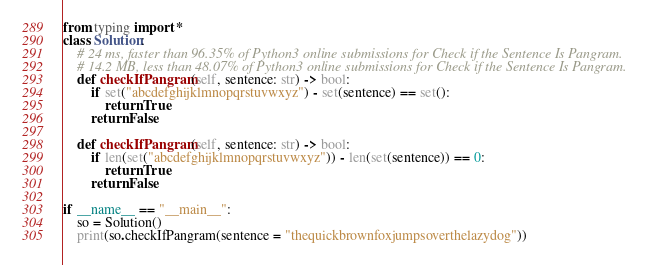Convert code to text. <code><loc_0><loc_0><loc_500><loc_500><_Python_>from typing import *
class Solution:
    # 24 ms, faster than 96.35% of Python3 online submissions for Check if the Sentence Is Pangram.
    # 14.2 MB, less than 48.07% of Python3 online submissions for Check if the Sentence Is Pangram.
    def checkIfPangram(self, sentence: str) -> bool: 
        if set("abcdefghijklmnopqrstuvwxyz") - set(sentence) == set():
            return True
        return False

    def checkIfPangram(self, sentence: str) -> bool: 
        if len(set("abcdefghijklmnopqrstuvwxyz")) - len(set(sentence)) == 0:
            return True
        return False

if __name__ == "__main__":
    so = Solution()
    print(so.checkIfPangram(sentence = "thequickbrownfoxjumpsoverthelazydog"))</code> 